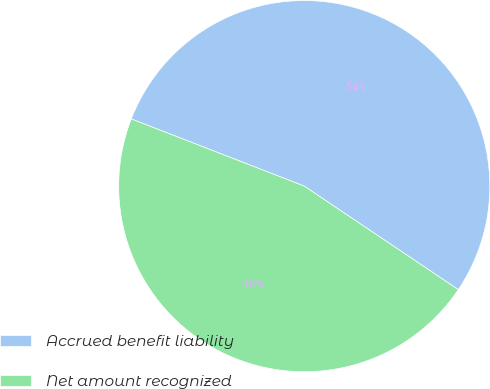<chart> <loc_0><loc_0><loc_500><loc_500><pie_chart><fcel>Accrued benefit liability<fcel>Net amount recognized<nl><fcel>53.52%<fcel>46.48%<nl></chart> 